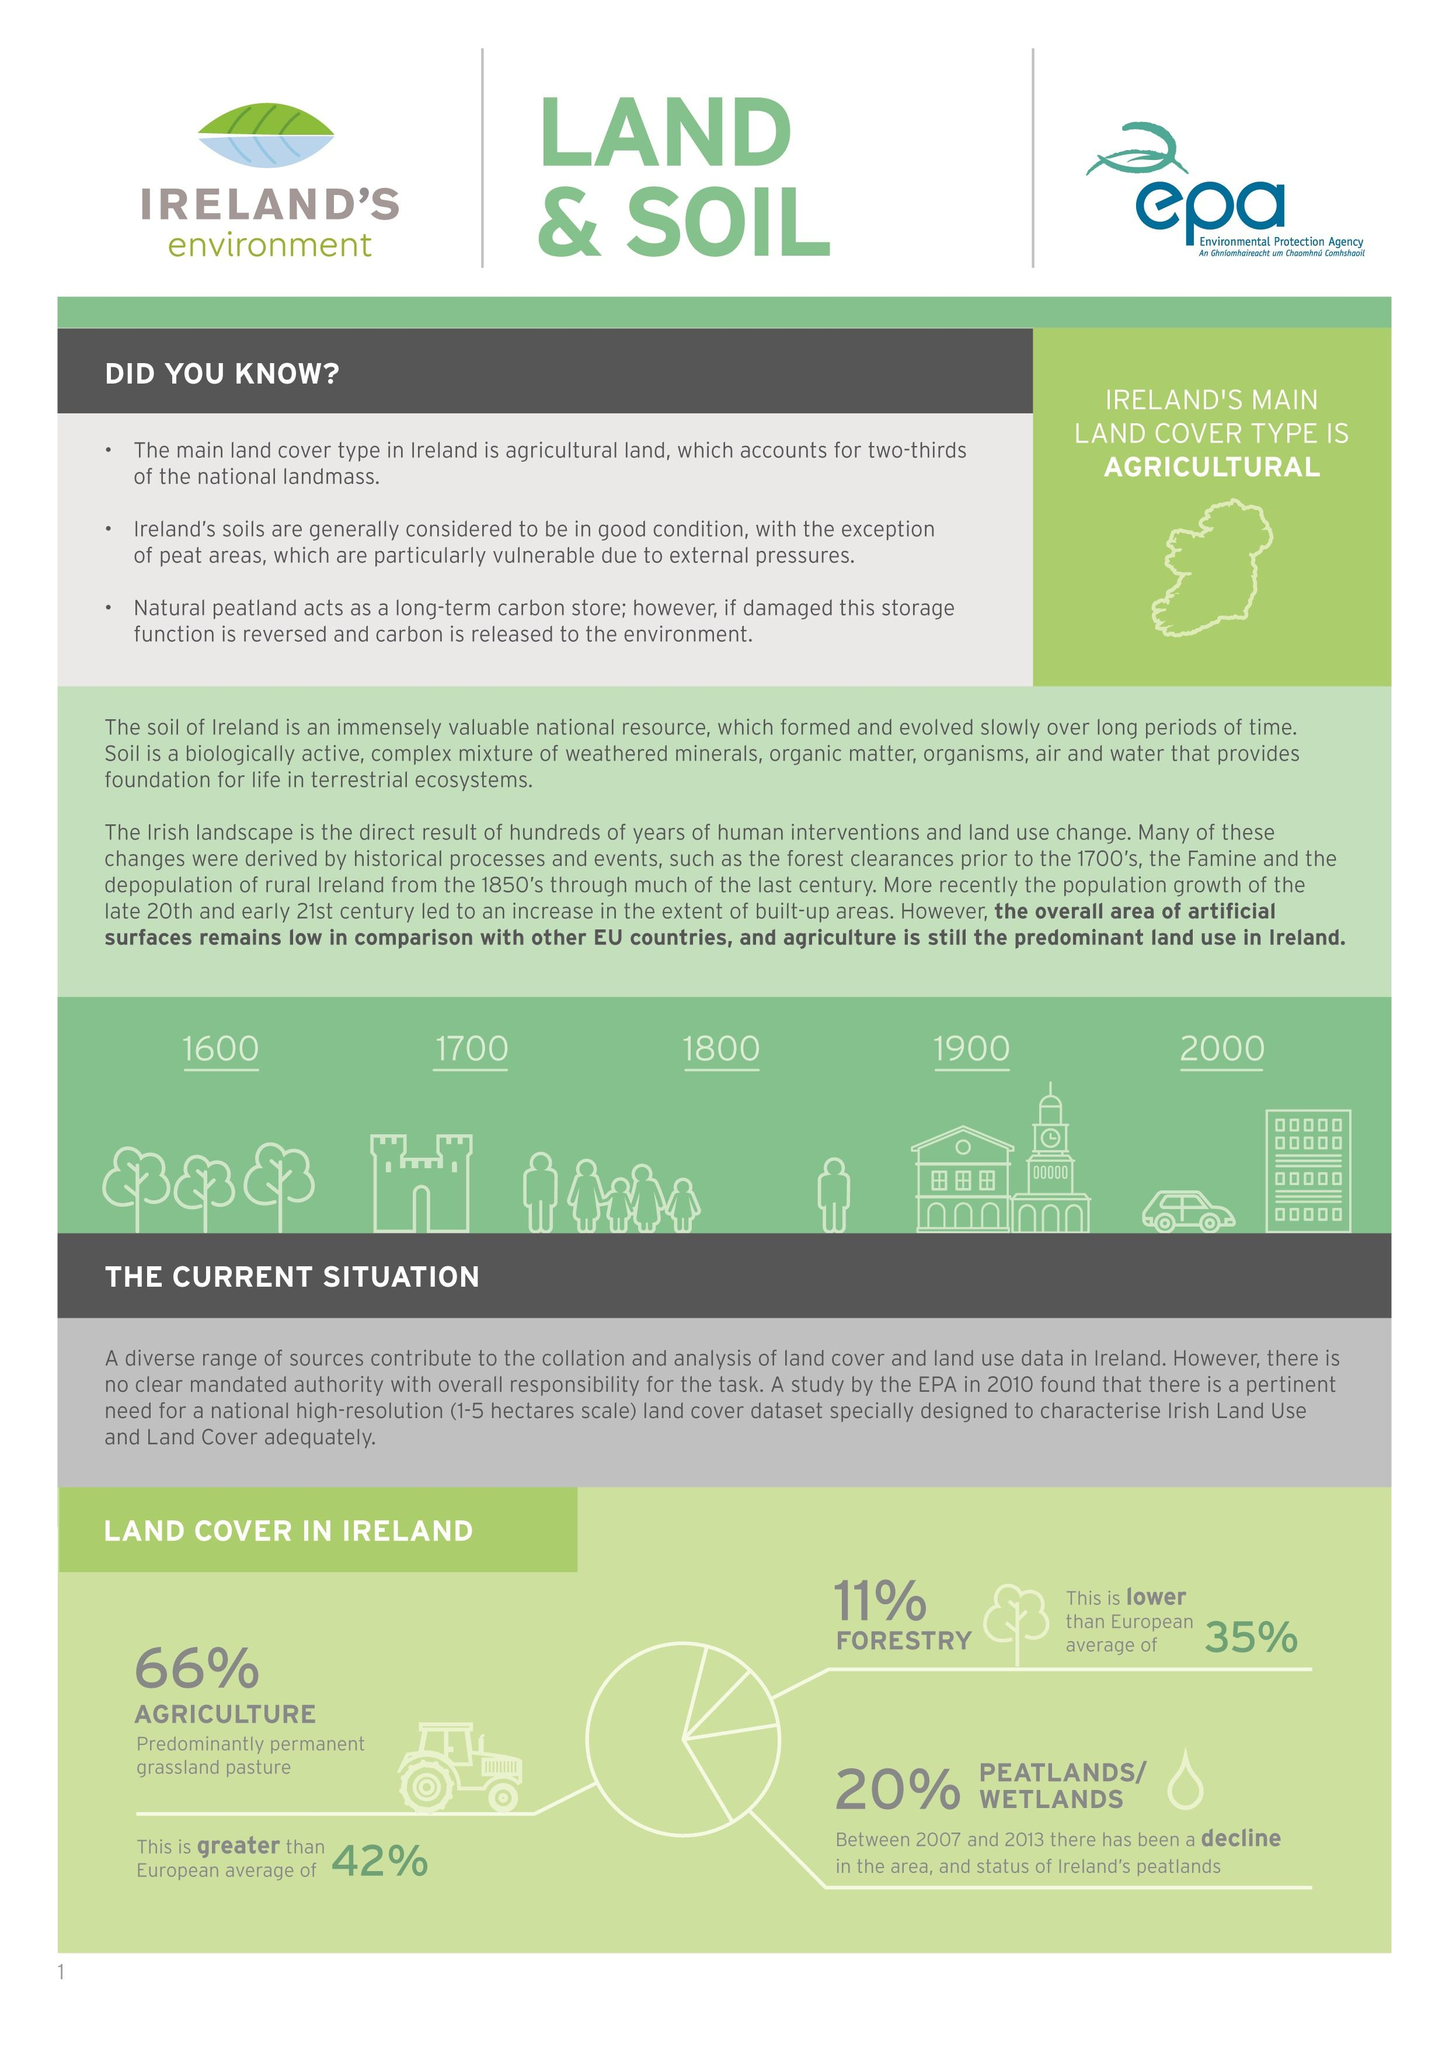Specify some key components in this picture. Approximately 20% of Ireland's land area is comprised of peatlands and wetlands. In summary, the major land cover of Ireland is primarily agricultural in nature. A significant 66% of Ireland's land area is devoted to agriculture. It is estimated that approximately 11% of Ireland's land area is covered by forests. 